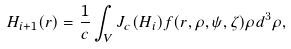Convert formula to latex. <formula><loc_0><loc_0><loc_500><loc_500>H _ { i + 1 } ( r ) = \frac { 1 } { c } \int _ { V } J _ { c } ( H _ { i } ) f ( r , \rho , \psi , \zeta ) \rho d ^ { 3 } \rho ,</formula> 